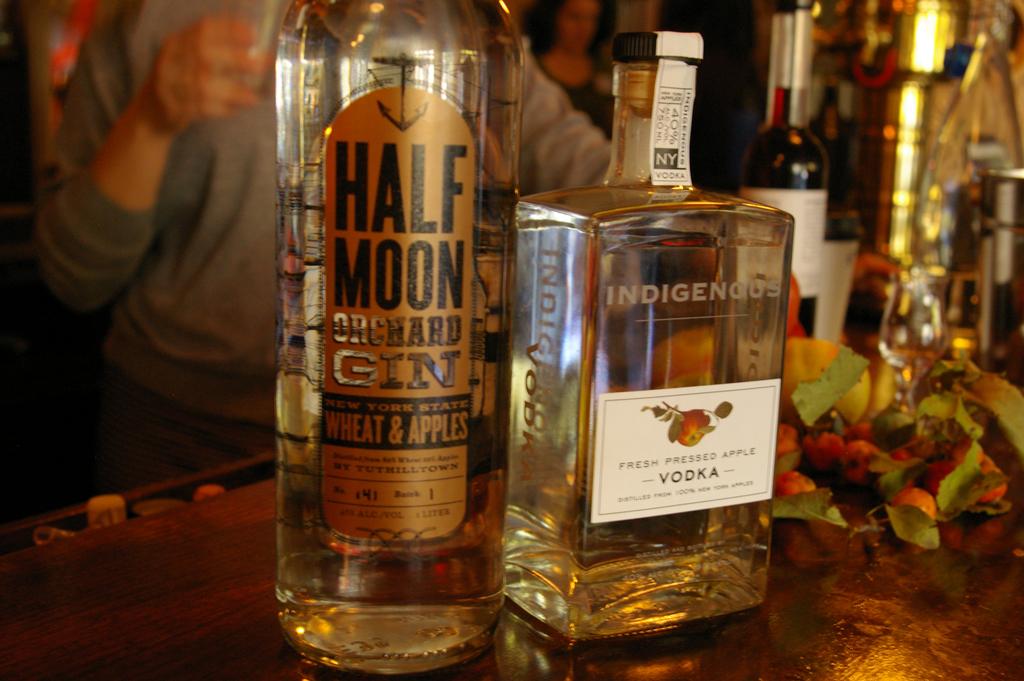What is the name of the gin?
Keep it short and to the point. Half moon. What is the name of the vodka?
Make the answer very short. Indigenous. 